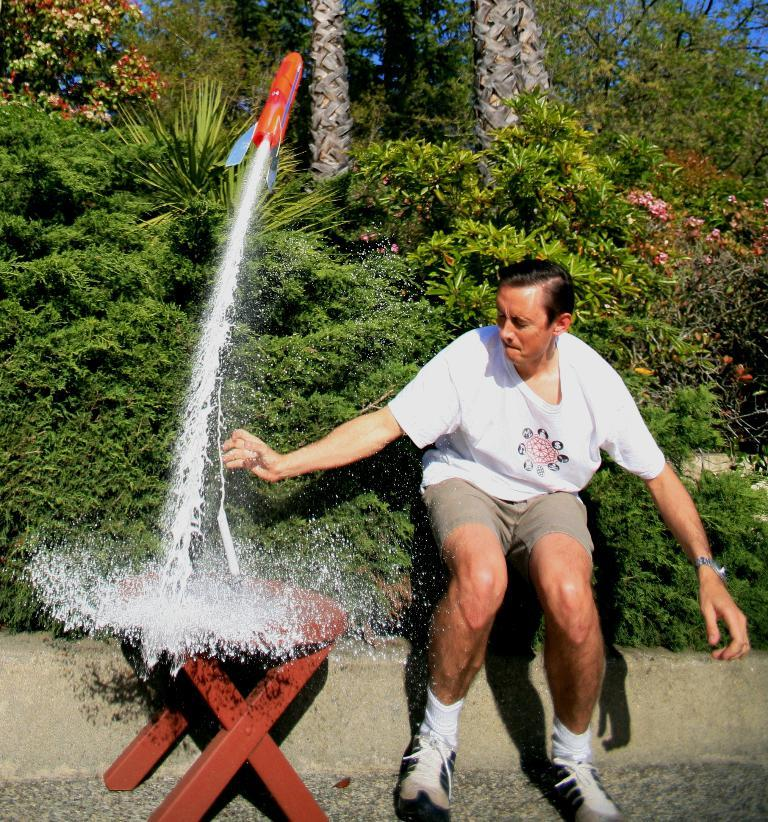What is the person wearing in the image? The person is wearing a white shirt in the image. What activity is the person engaged in? The person is playing with a toy rocket. What piece of furniture is present in the image? There is a table in the image. What can be seen in the background of the image? There are trees and plants in the background of the image. Where is the shelf located in the image? There is no shelf present in the image. What type of bag is the person holding in the image? There is no bag present in the image. 